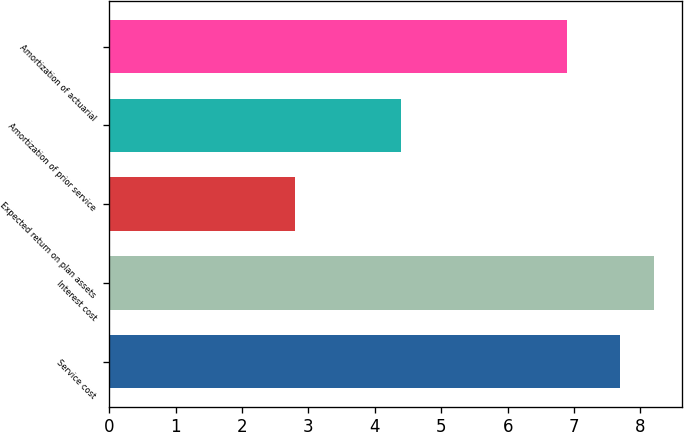Convert chart to OTSL. <chart><loc_0><loc_0><loc_500><loc_500><bar_chart><fcel>Service cost<fcel>Interest cost<fcel>Expected return on plan assets<fcel>Amortization of prior service<fcel>Amortization of actuarial<nl><fcel>7.7<fcel>8.21<fcel>2.8<fcel>4.4<fcel>6.9<nl></chart> 